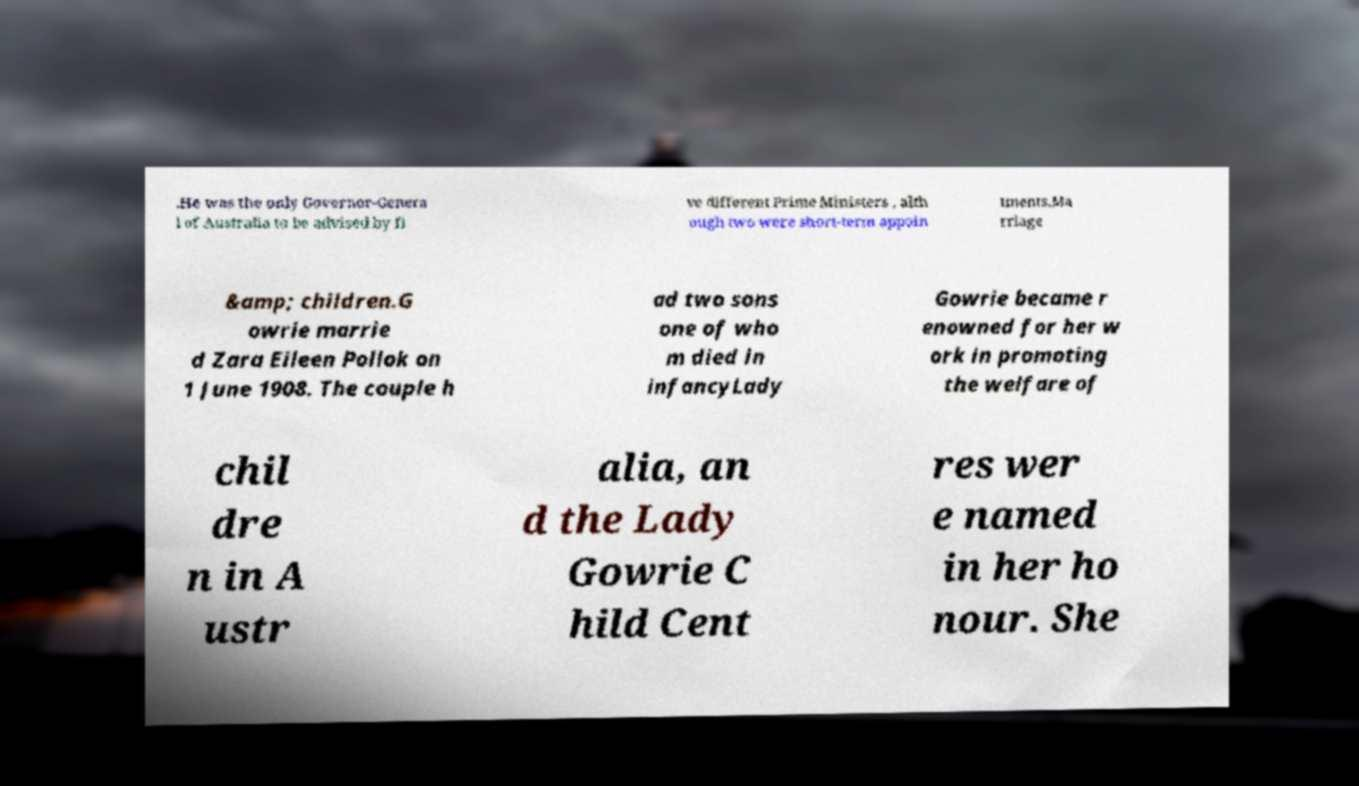Could you extract and type out the text from this image? .He was the only Governor-Genera l of Australia to be advised by fi ve different Prime Ministers , alth ough two were short-term appoin tments.Ma rriage &amp; children.G owrie marrie d Zara Eileen Pollok on 1 June 1908. The couple h ad two sons one of who m died in infancyLady Gowrie became r enowned for her w ork in promoting the welfare of chil dre n in A ustr alia, an d the Lady Gowrie C hild Cent res wer e named in her ho nour. She 